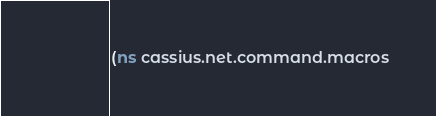<code> <loc_0><loc_0><loc_500><loc_500><_Clojure_>(ns cassius.net.command.macros</code> 